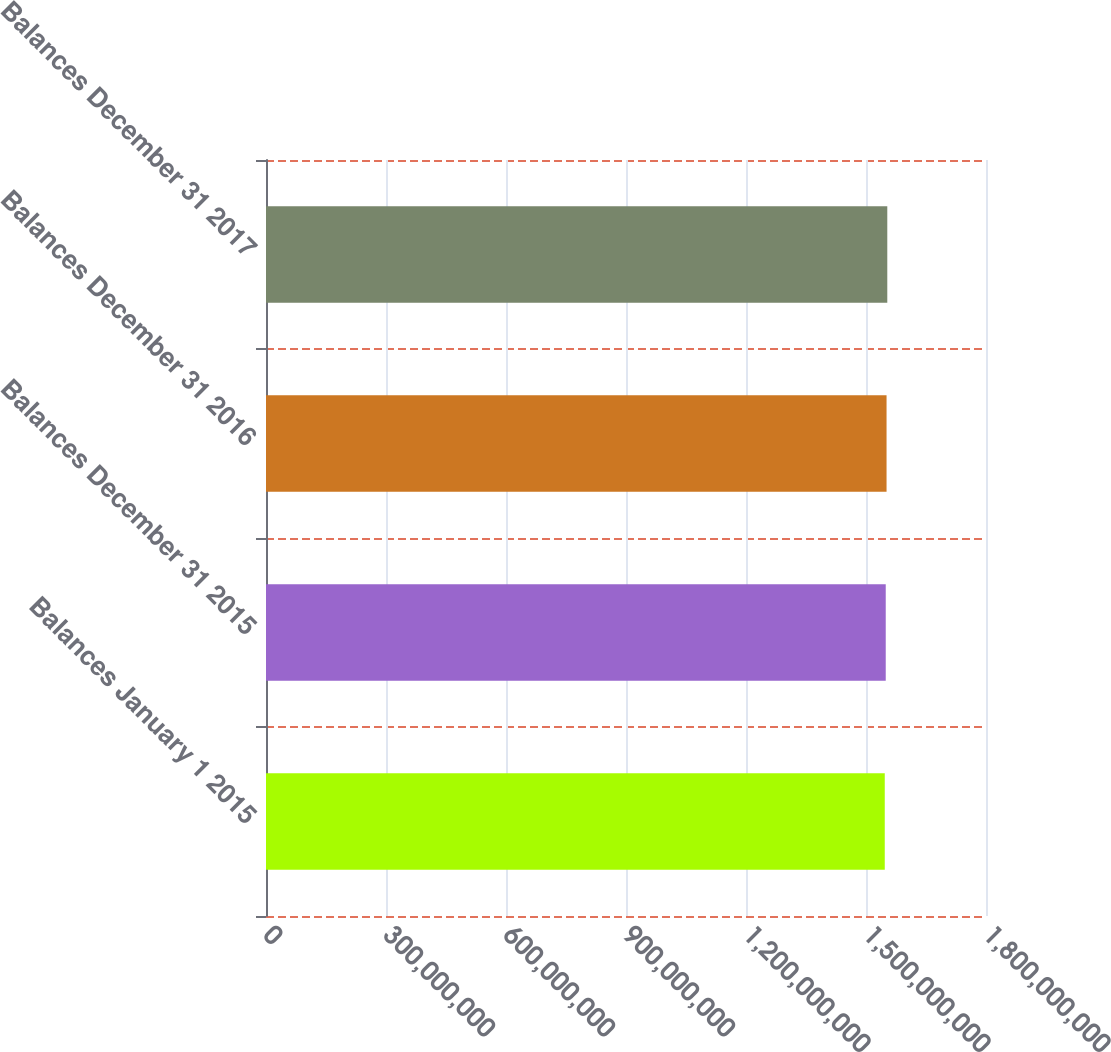<chart> <loc_0><loc_0><loc_500><loc_500><bar_chart><fcel>Balances January 1 2015<fcel>Balances December 31 2015<fcel>Balances December 31 2016<fcel>Balances December 31 2017<nl><fcel>1.5469e+09<fcel>1.54934e+09<fcel>1.55139e+09<fcel>1.55322e+09<nl></chart> 